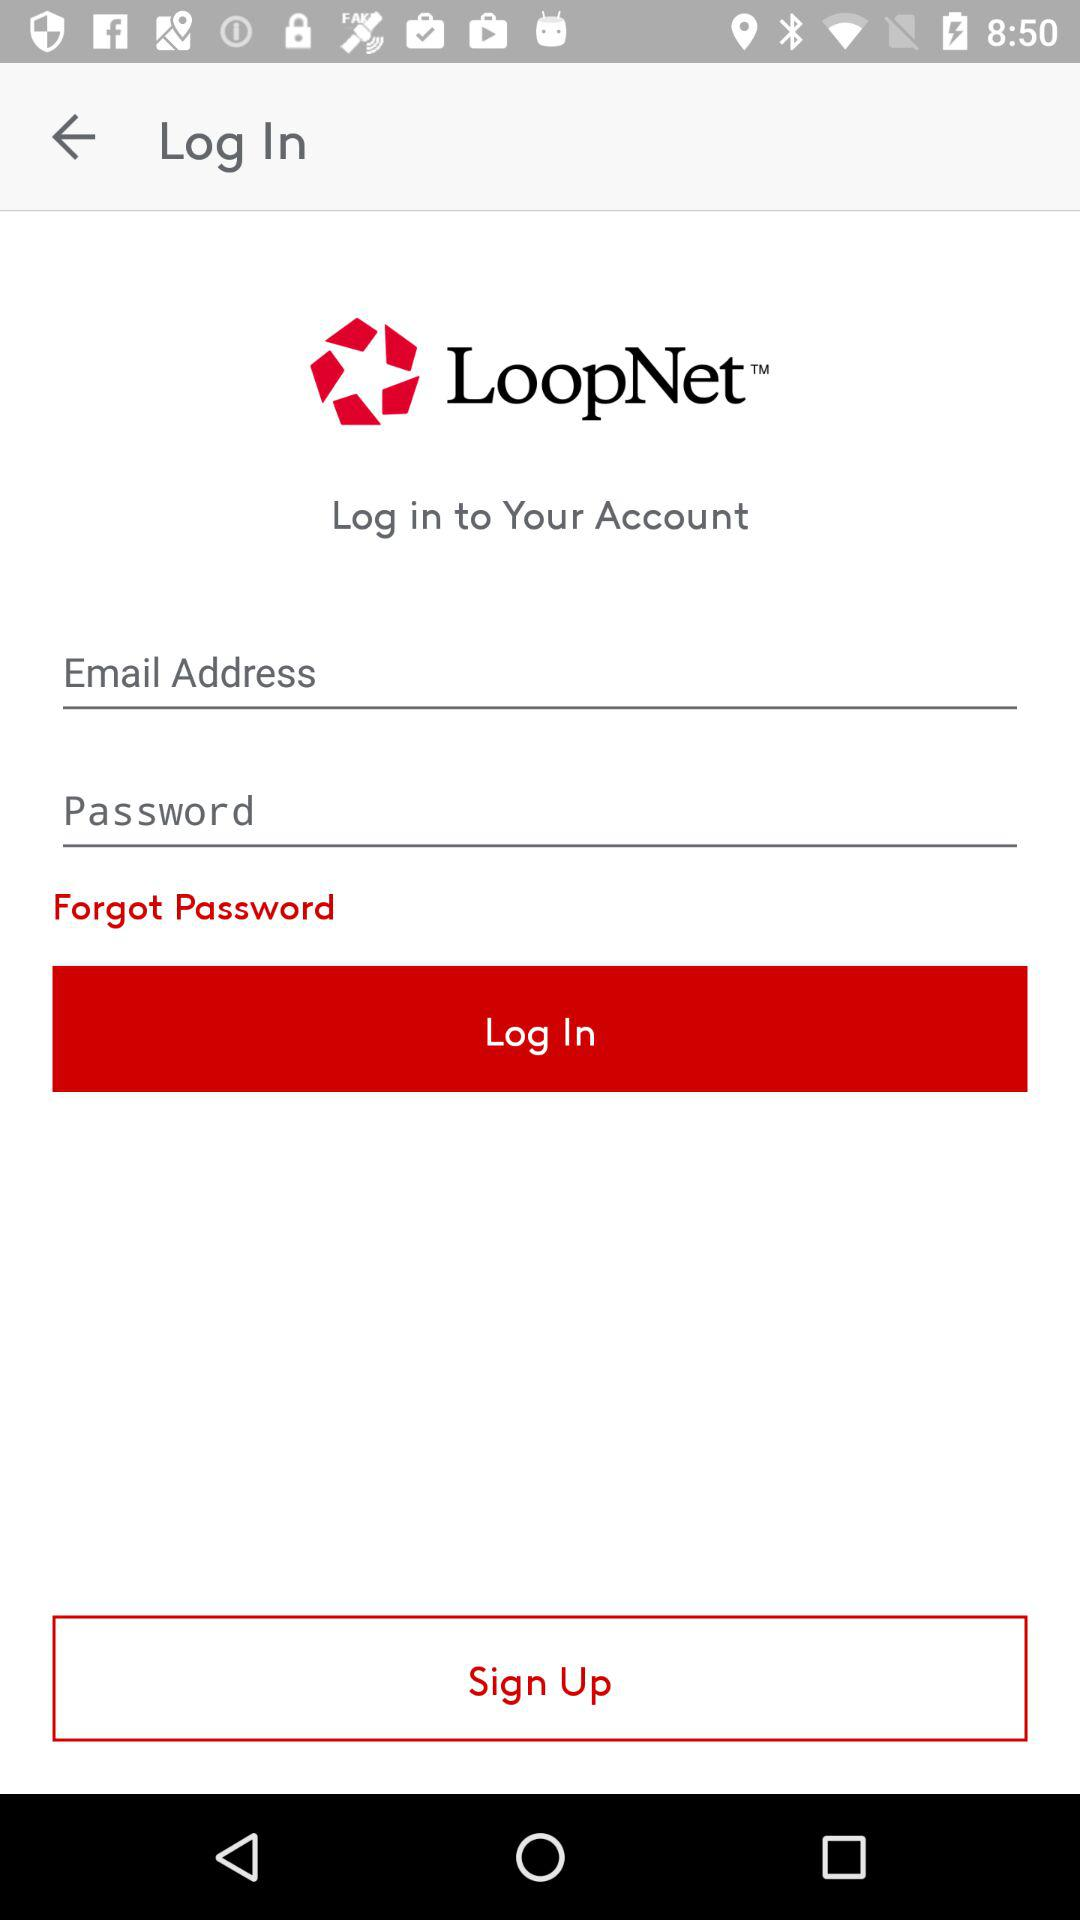What is the application name? The application name is "LoopNet". 